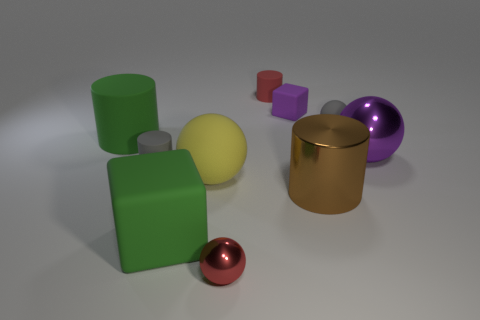Subtract all gray matte balls. How many balls are left? 3 Subtract 1 blocks. How many blocks are left? 1 Subtract all cubes. How many objects are left? 8 Subtract all red balls. How many balls are left? 3 Add 5 matte cylinders. How many matte cylinders exist? 8 Subtract 0 yellow blocks. How many objects are left? 10 Subtract all brown balls. Subtract all purple blocks. How many balls are left? 4 Subtract all red cylinders. Subtract all gray rubber balls. How many objects are left? 8 Add 5 large metallic objects. How many large metallic objects are left? 7 